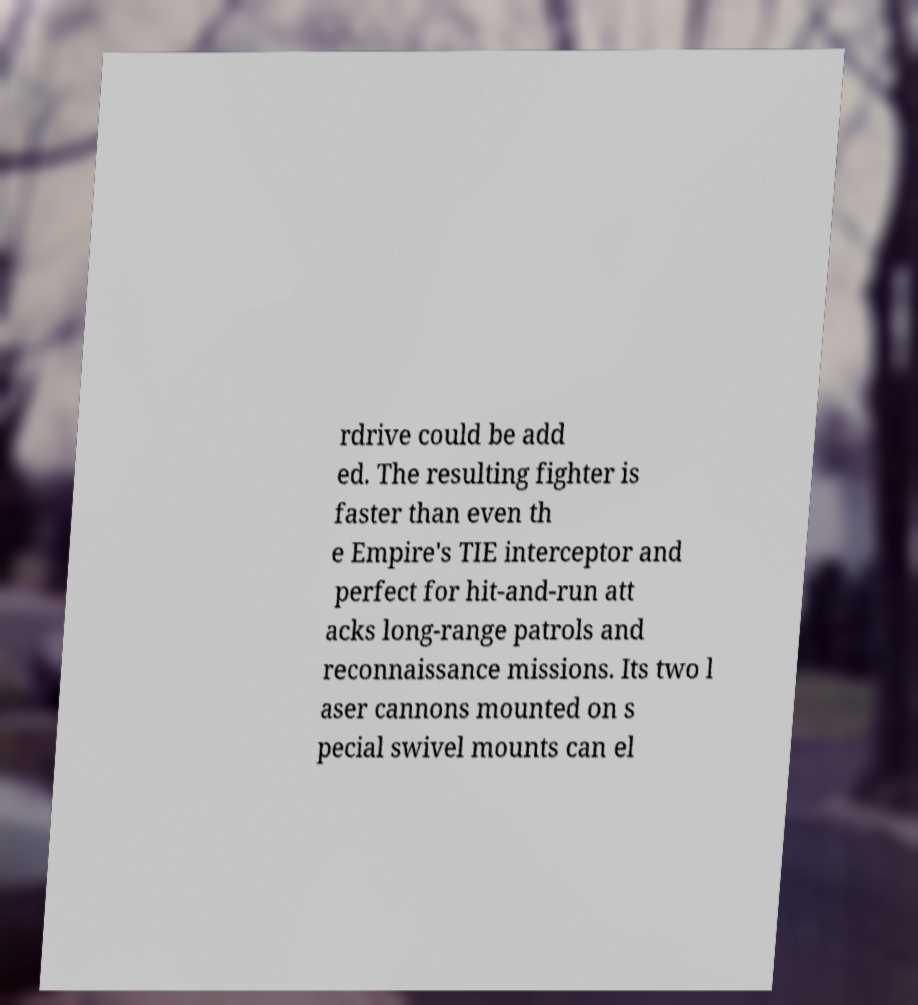Please read and relay the text visible in this image. What does it say? rdrive could be add ed. The resulting fighter is faster than even th e Empire's TIE interceptor and perfect for hit-and-run att acks long-range patrols and reconnaissance missions. Its two l aser cannons mounted on s pecial swivel mounts can el 